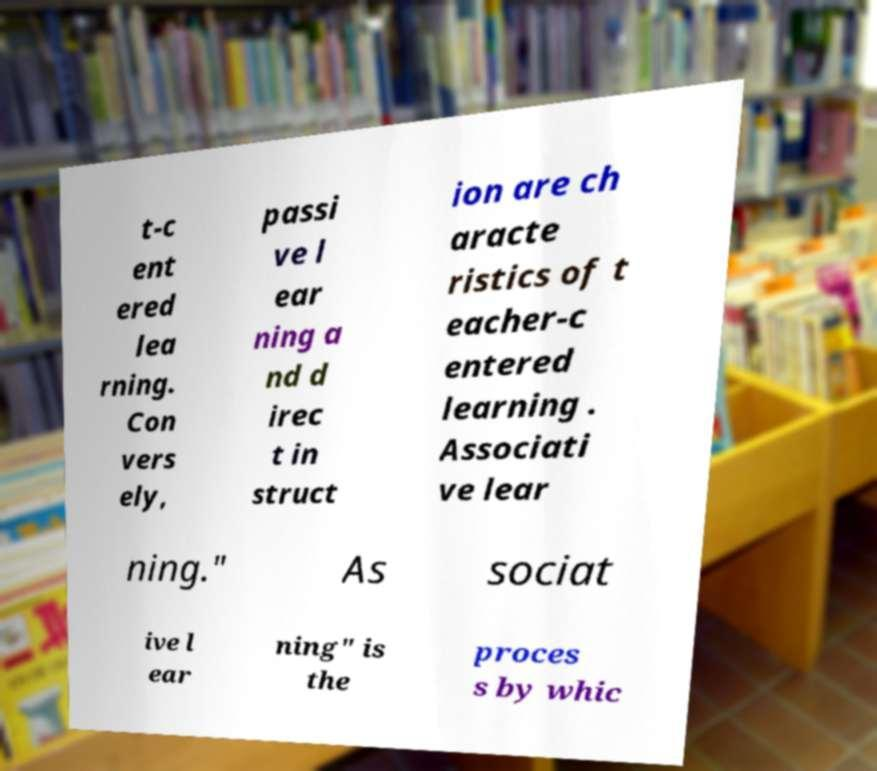There's text embedded in this image that I need extracted. Can you transcribe it verbatim? t-c ent ered lea rning. Con vers ely, passi ve l ear ning a nd d irec t in struct ion are ch aracte ristics of t eacher-c entered learning . Associati ve lear ning." As sociat ive l ear ning" is the proces s by whic 